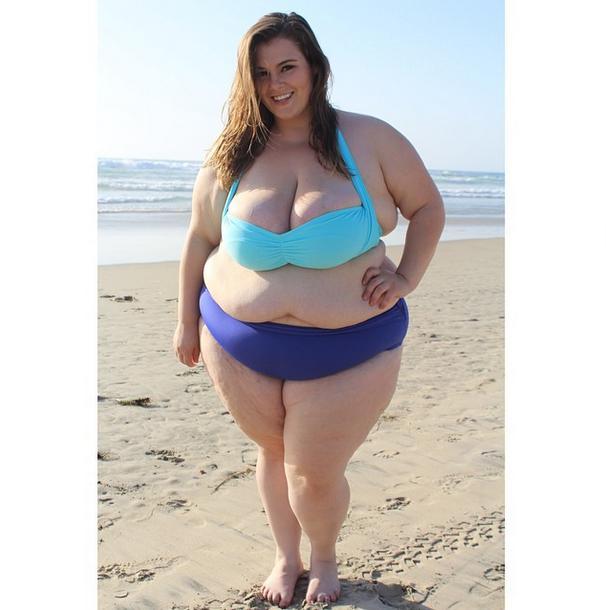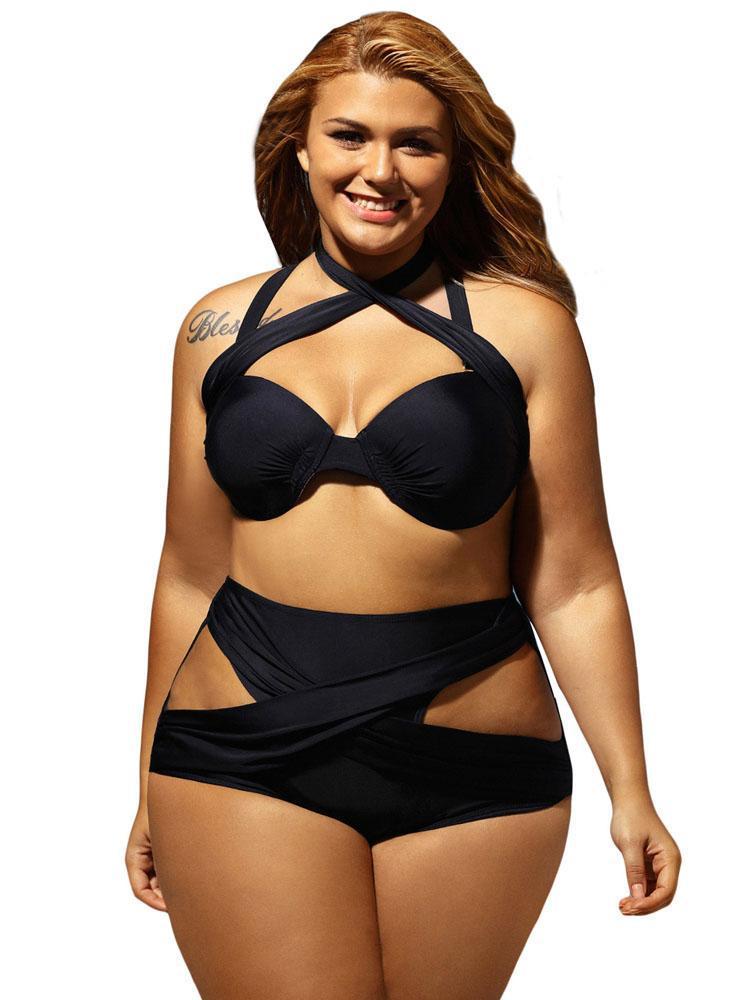The first image is the image on the left, the second image is the image on the right. For the images displayed, is the sentence "At least one image features a model in matching-colored solid aqua bikini." factually correct? Answer yes or no. No. The first image is the image on the left, the second image is the image on the right. For the images shown, is this caption "There are two bikinis that are primarily blue in color" true? Answer yes or no. No. 